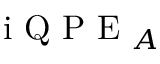<formula> <loc_0><loc_0><loc_500><loc_500>i Q P E _ { A }</formula> 